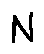Convert formula to latex. <formula><loc_0><loc_0><loc_500><loc_500>N</formula> 